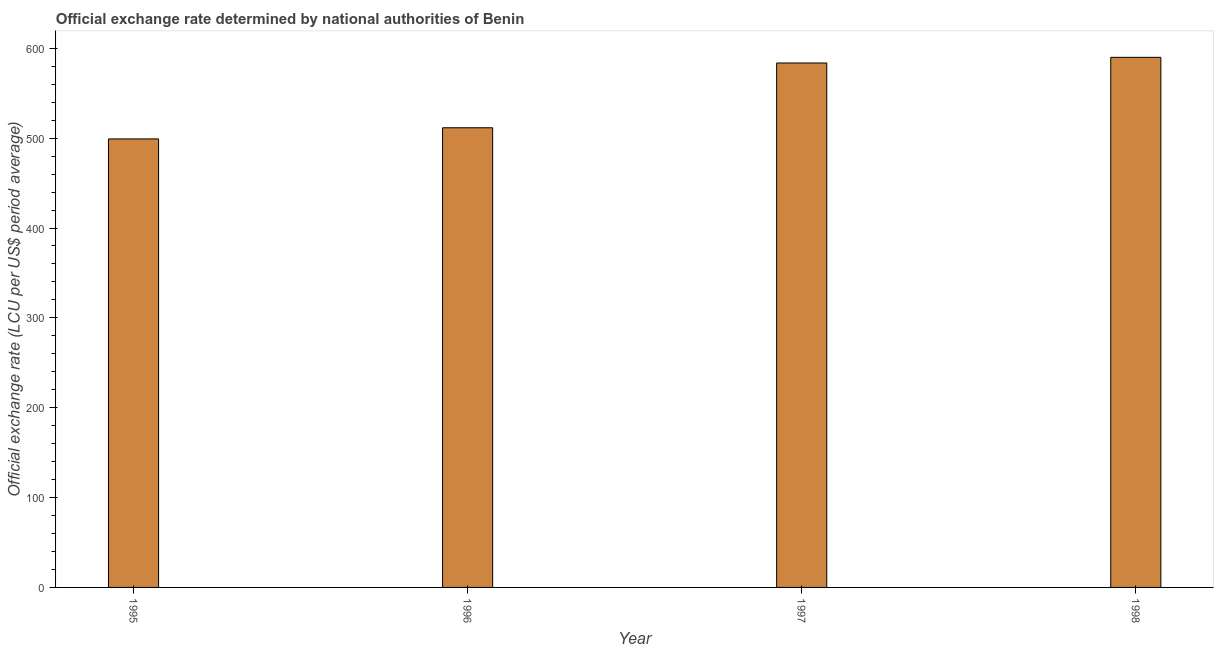Does the graph contain any zero values?
Ensure brevity in your answer.  No. Does the graph contain grids?
Give a very brief answer. No. What is the title of the graph?
Offer a very short reply. Official exchange rate determined by national authorities of Benin. What is the label or title of the X-axis?
Make the answer very short. Year. What is the label or title of the Y-axis?
Offer a very short reply. Official exchange rate (LCU per US$ period average). What is the official exchange rate in 1995?
Ensure brevity in your answer.  499.15. Across all years, what is the maximum official exchange rate?
Keep it short and to the point. 589.95. Across all years, what is the minimum official exchange rate?
Your answer should be very brief. 499.15. In which year was the official exchange rate minimum?
Provide a succinct answer. 1995. What is the sum of the official exchange rate?
Your answer should be compact. 2184.32. What is the difference between the official exchange rate in 1996 and 1997?
Offer a terse response. -72.12. What is the average official exchange rate per year?
Your answer should be very brief. 546.08. What is the median official exchange rate?
Your answer should be very brief. 547.61. Do a majority of the years between 1995 and 1997 (inclusive) have official exchange rate greater than 420 ?
Ensure brevity in your answer.  Yes. What is the ratio of the official exchange rate in 1995 to that in 1997?
Your response must be concise. 0.85. Is the official exchange rate in 1995 less than that in 1998?
Make the answer very short. Yes. Is the difference between the official exchange rate in 1997 and 1998 greater than the difference between any two years?
Keep it short and to the point. No. What is the difference between the highest and the second highest official exchange rate?
Offer a terse response. 6.28. What is the difference between the highest and the lowest official exchange rate?
Your response must be concise. 90.8. How many bars are there?
Make the answer very short. 4. Are all the bars in the graph horizontal?
Provide a succinct answer. No. What is the difference between two consecutive major ticks on the Y-axis?
Offer a terse response. 100. Are the values on the major ticks of Y-axis written in scientific E-notation?
Offer a terse response. No. What is the Official exchange rate (LCU per US$ period average) in 1995?
Offer a terse response. 499.15. What is the Official exchange rate (LCU per US$ period average) in 1996?
Give a very brief answer. 511.55. What is the Official exchange rate (LCU per US$ period average) of 1997?
Keep it short and to the point. 583.67. What is the Official exchange rate (LCU per US$ period average) of 1998?
Your answer should be compact. 589.95. What is the difference between the Official exchange rate (LCU per US$ period average) in 1995 and 1996?
Offer a very short reply. -12.4. What is the difference between the Official exchange rate (LCU per US$ period average) in 1995 and 1997?
Keep it short and to the point. -84.52. What is the difference between the Official exchange rate (LCU per US$ period average) in 1995 and 1998?
Your answer should be compact. -90.8. What is the difference between the Official exchange rate (LCU per US$ period average) in 1996 and 1997?
Your answer should be very brief. -72.12. What is the difference between the Official exchange rate (LCU per US$ period average) in 1996 and 1998?
Make the answer very short. -78.4. What is the difference between the Official exchange rate (LCU per US$ period average) in 1997 and 1998?
Make the answer very short. -6.28. What is the ratio of the Official exchange rate (LCU per US$ period average) in 1995 to that in 1997?
Keep it short and to the point. 0.85. What is the ratio of the Official exchange rate (LCU per US$ period average) in 1995 to that in 1998?
Offer a terse response. 0.85. What is the ratio of the Official exchange rate (LCU per US$ period average) in 1996 to that in 1997?
Provide a short and direct response. 0.88. What is the ratio of the Official exchange rate (LCU per US$ period average) in 1996 to that in 1998?
Make the answer very short. 0.87. 